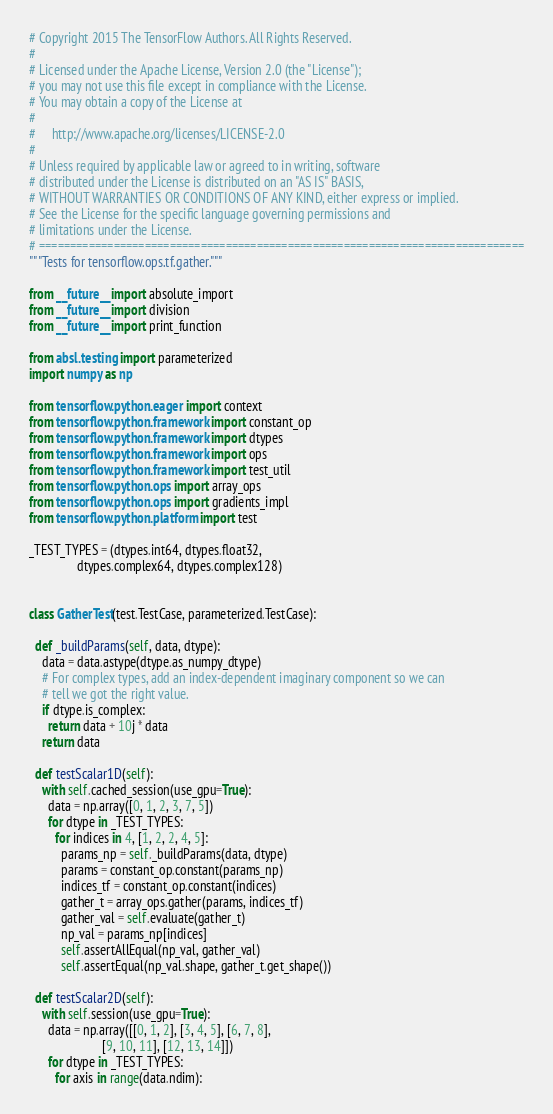<code> <loc_0><loc_0><loc_500><loc_500><_Python_># Copyright 2015 The TensorFlow Authors. All Rights Reserved.
#
# Licensed under the Apache License, Version 2.0 (the "License");
# you may not use this file except in compliance with the License.
# You may obtain a copy of the License at
#
#     http://www.apache.org/licenses/LICENSE-2.0
#
# Unless required by applicable law or agreed to in writing, software
# distributed under the License is distributed on an "AS IS" BASIS,
# WITHOUT WARRANTIES OR CONDITIONS OF ANY KIND, either express or implied.
# See the License for the specific language governing permissions and
# limitations under the License.
# ==============================================================================
"""Tests for tensorflow.ops.tf.gather."""

from __future__ import absolute_import
from __future__ import division
from __future__ import print_function

from absl.testing import parameterized
import numpy as np

from tensorflow.python.eager import context
from tensorflow.python.framework import constant_op
from tensorflow.python.framework import dtypes
from tensorflow.python.framework import ops
from tensorflow.python.framework import test_util
from tensorflow.python.ops import array_ops
from tensorflow.python.ops import gradients_impl
from tensorflow.python.platform import test

_TEST_TYPES = (dtypes.int64, dtypes.float32,
               dtypes.complex64, dtypes.complex128)


class GatherTest(test.TestCase, parameterized.TestCase):

  def _buildParams(self, data, dtype):
    data = data.astype(dtype.as_numpy_dtype)
    # For complex types, add an index-dependent imaginary component so we can
    # tell we got the right value.
    if dtype.is_complex:
      return data + 10j * data
    return data

  def testScalar1D(self):
    with self.cached_session(use_gpu=True):
      data = np.array([0, 1, 2, 3, 7, 5])
      for dtype in _TEST_TYPES:
        for indices in 4, [1, 2, 2, 4, 5]:
          params_np = self._buildParams(data, dtype)
          params = constant_op.constant(params_np)
          indices_tf = constant_op.constant(indices)
          gather_t = array_ops.gather(params, indices_tf)
          gather_val = self.evaluate(gather_t)
          np_val = params_np[indices]
          self.assertAllEqual(np_val, gather_val)
          self.assertEqual(np_val.shape, gather_t.get_shape())

  def testScalar2D(self):
    with self.session(use_gpu=True):
      data = np.array([[0, 1, 2], [3, 4, 5], [6, 7, 8],
                       [9, 10, 11], [12, 13, 14]])
      for dtype in _TEST_TYPES:
        for axis in range(data.ndim):</code> 